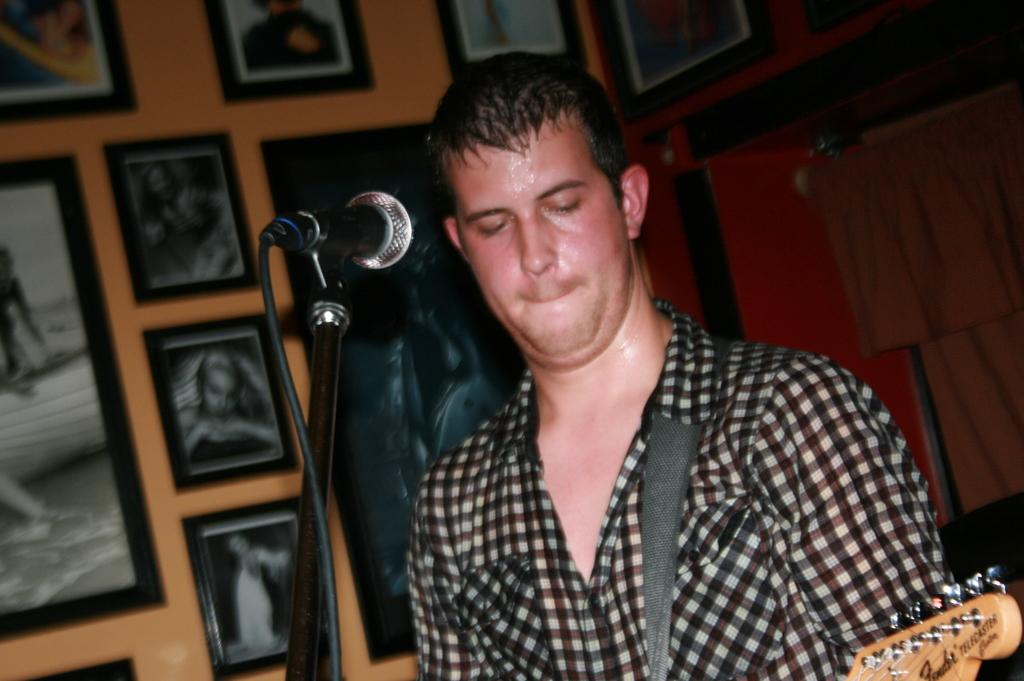Who is present in the image? There is a man in the image. What object is visible near the man? There is a microphone (mike) in the image. What color is the wall in the background of the image? There is an orange color wall in the image. What type of decoration can be seen on the wall? There are photo frames on the wall in the image. What type of pan is being used to cook breakfast in the image? There is no pan or breakfast present in the image; it only features a man, a microphone, an orange wall, and photo frames on the wall. 